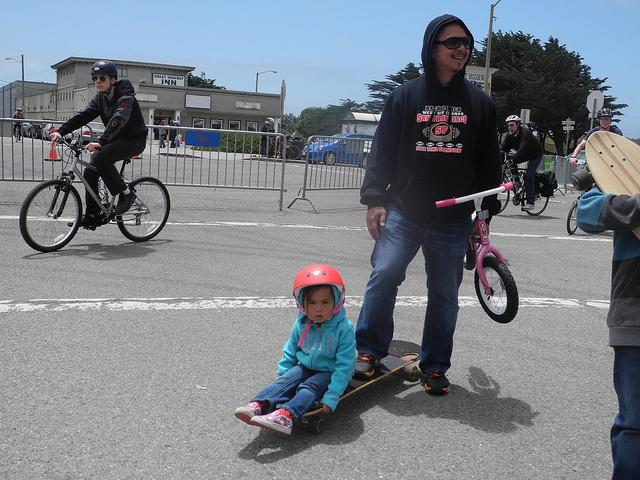Why is the child on the skateboard wearing a helmet? Please explain your reasoning. protection. People wear helmets for the purpose of protection and especially when engaging in skateboarding and if they are at a beginner level which a child this young would likely be. 